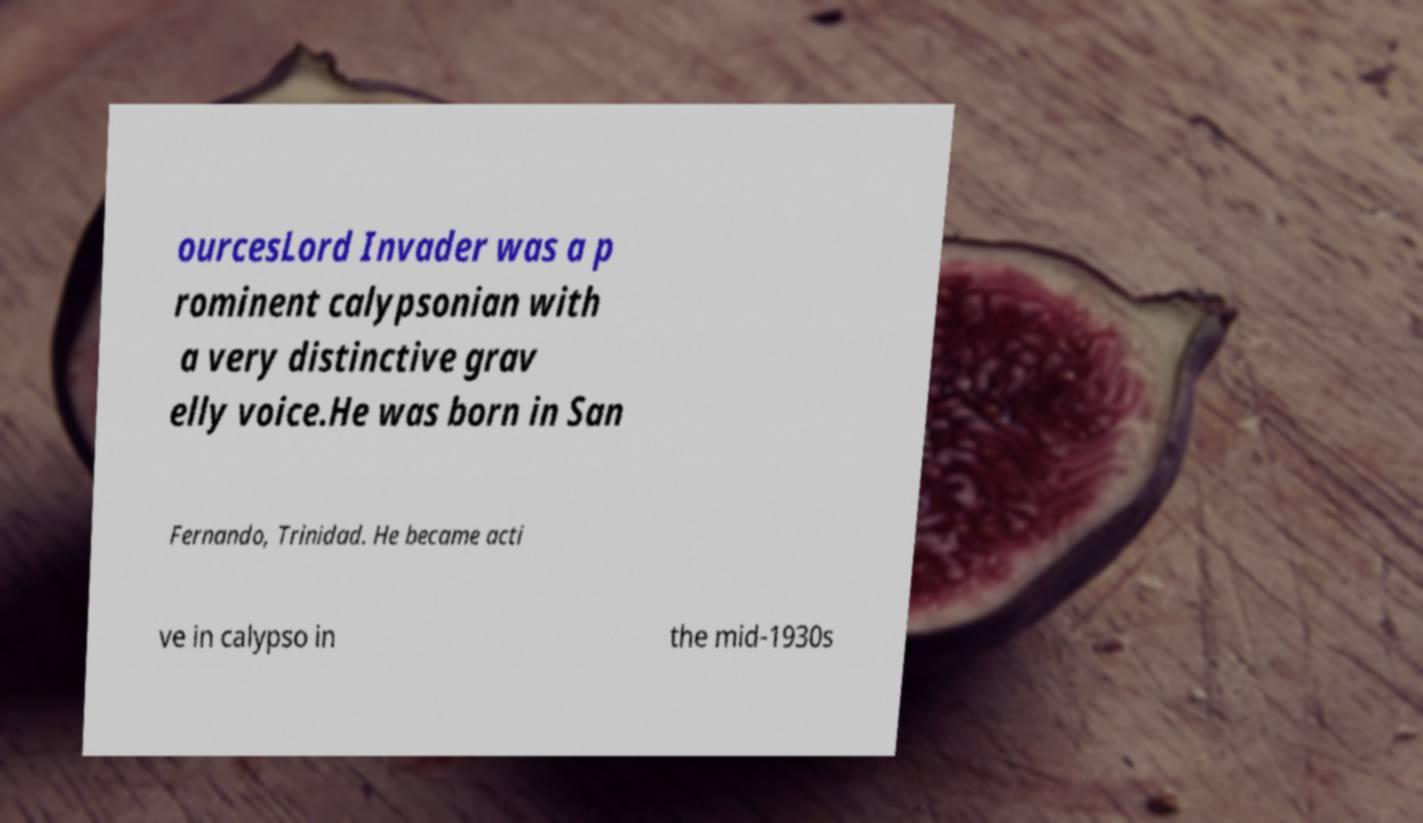Please read and relay the text visible in this image. What does it say? ourcesLord Invader was a p rominent calypsonian with a very distinctive grav elly voice.He was born in San Fernando, Trinidad. He became acti ve in calypso in the mid-1930s 